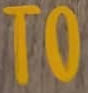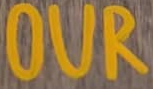Read the text content from these images in order, separated by a semicolon. TO; OUR 